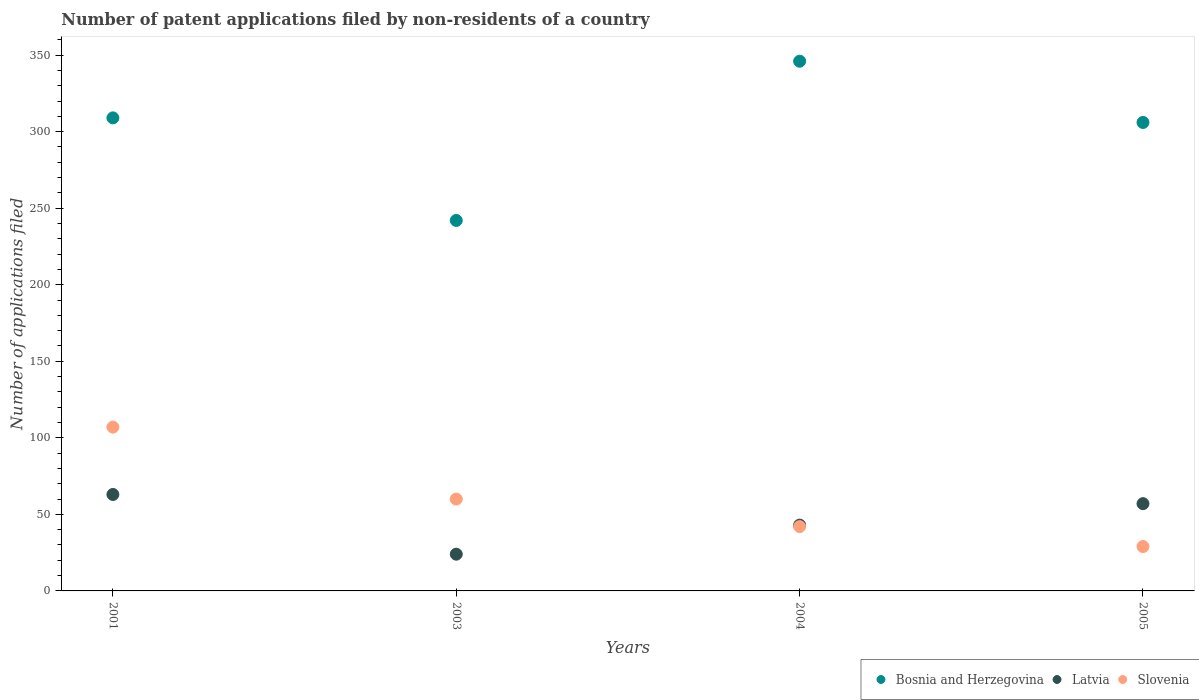How many different coloured dotlines are there?
Offer a terse response. 3. Is the number of dotlines equal to the number of legend labels?
Offer a very short reply. Yes. What is the number of applications filed in Slovenia in 2003?
Keep it short and to the point. 60. Across all years, what is the maximum number of applications filed in Bosnia and Herzegovina?
Offer a very short reply. 346. Across all years, what is the minimum number of applications filed in Slovenia?
Offer a terse response. 29. What is the total number of applications filed in Slovenia in the graph?
Keep it short and to the point. 238. What is the difference between the number of applications filed in Slovenia in 2004 and the number of applications filed in Latvia in 2005?
Keep it short and to the point. -15. What is the average number of applications filed in Bosnia and Herzegovina per year?
Provide a short and direct response. 300.75. In the year 2003, what is the difference between the number of applications filed in Bosnia and Herzegovina and number of applications filed in Slovenia?
Provide a short and direct response. 182. What is the ratio of the number of applications filed in Slovenia in 2003 to that in 2004?
Provide a short and direct response. 1.43. Is the number of applications filed in Bosnia and Herzegovina in 2001 less than that in 2003?
Your response must be concise. No. Does the number of applications filed in Latvia monotonically increase over the years?
Give a very brief answer. No. What is the difference between two consecutive major ticks on the Y-axis?
Make the answer very short. 50. Does the graph contain any zero values?
Provide a short and direct response. No. Where does the legend appear in the graph?
Provide a succinct answer. Bottom right. How many legend labels are there?
Keep it short and to the point. 3. What is the title of the graph?
Provide a short and direct response. Number of patent applications filed by non-residents of a country. What is the label or title of the Y-axis?
Make the answer very short. Number of applications filed. What is the Number of applications filed in Bosnia and Herzegovina in 2001?
Ensure brevity in your answer.  309. What is the Number of applications filed of Slovenia in 2001?
Make the answer very short. 107. What is the Number of applications filed in Bosnia and Herzegovina in 2003?
Ensure brevity in your answer.  242. What is the Number of applications filed of Latvia in 2003?
Your answer should be very brief. 24. What is the Number of applications filed in Bosnia and Herzegovina in 2004?
Give a very brief answer. 346. What is the Number of applications filed of Bosnia and Herzegovina in 2005?
Offer a very short reply. 306. What is the Number of applications filed of Latvia in 2005?
Your answer should be compact. 57. Across all years, what is the maximum Number of applications filed in Bosnia and Herzegovina?
Ensure brevity in your answer.  346. Across all years, what is the maximum Number of applications filed in Slovenia?
Provide a short and direct response. 107. Across all years, what is the minimum Number of applications filed in Bosnia and Herzegovina?
Ensure brevity in your answer.  242. Across all years, what is the minimum Number of applications filed in Slovenia?
Ensure brevity in your answer.  29. What is the total Number of applications filed in Bosnia and Herzegovina in the graph?
Give a very brief answer. 1203. What is the total Number of applications filed of Latvia in the graph?
Give a very brief answer. 187. What is the total Number of applications filed in Slovenia in the graph?
Keep it short and to the point. 238. What is the difference between the Number of applications filed in Bosnia and Herzegovina in 2001 and that in 2003?
Your response must be concise. 67. What is the difference between the Number of applications filed in Latvia in 2001 and that in 2003?
Keep it short and to the point. 39. What is the difference between the Number of applications filed of Slovenia in 2001 and that in 2003?
Provide a short and direct response. 47. What is the difference between the Number of applications filed in Bosnia and Herzegovina in 2001 and that in 2004?
Your answer should be very brief. -37. What is the difference between the Number of applications filed of Slovenia in 2001 and that in 2004?
Keep it short and to the point. 65. What is the difference between the Number of applications filed in Bosnia and Herzegovina in 2001 and that in 2005?
Give a very brief answer. 3. What is the difference between the Number of applications filed in Latvia in 2001 and that in 2005?
Your response must be concise. 6. What is the difference between the Number of applications filed of Bosnia and Herzegovina in 2003 and that in 2004?
Ensure brevity in your answer.  -104. What is the difference between the Number of applications filed of Latvia in 2003 and that in 2004?
Provide a succinct answer. -19. What is the difference between the Number of applications filed of Bosnia and Herzegovina in 2003 and that in 2005?
Provide a succinct answer. -64. What is the difference between the Number of applications filed in Latvia in 2003 and that in 2005?
Your answer should be compact. -33. What is the difference between the Number of applications filed in Slovenia in 2003 and that in 2005?
Provide a succinct answer. 31. What is the difference between the Number of applications filed in Latvia in 2004 and that in 2005?
Make the answer very short. -14. What is the difference between the Number of applications filed of Bosnia and Herzegovina in 2001 and the Number of applications filed of Latvia in 2003?
Make the answer very short. 285. What is the difference between the Number of applications filed of Bosnia and Herzegovina in 2001 and the Number of applications filed of Slovenia in 2003?
Provide a succinct answer. 249. What is the difference between the Number of applications filed in Bosnia and Herzegovina in 2001 and the Number of applications filed in Latvia in 2004?
Your response must be concise. 266. What is the difference between the Number of applications filed in Bosnia and Herzegovina in 2001 and the Number of applications filed in Slovenia in 2004?
Give a very brief answer. 267. What is the difference between the Number of applications filed in Bosnia and Herzegovina in 2001 and the Number of applications filed in Latvia in 2005?
Ensure brevity in your answer.  252. What is the difference between the Number of applications filed in Bosnia and Herzegovina in 2001 and the Number of applications filed in Slovenia in 2005?
Your answer should be very brief. 280. What is the difference between the Number of applications filed of Latvia in 2001 and the Number of applications filed of Slovenia in 2005?
Your answer should be compact. 34. What is the difference between the Number of applications filed of Bosnia and Herzegovina in 2003 and the Number of applications filed of Latvia in 2004?
Make the answer very short. 199. What is the difference between the Number of applications filed in Latvia in 2003 and the Number of applications filed in Slovenia in 2004?
Ensure brevity in your answer.  -18. What is the difference between the Number of applications filed in Bosnia and Herzegovina in 2003 and the Number of applications filed in Latvia in 2005?
Your answer should be very brief. 185. What is the difference between the Number of applications filed in Bosnia and Herzegovina in 2003 and the Number of applications filed in Slovenia in 2005?
Provide a short and direct response. 213. What is the difference between the Number of applications filed in Bosnia and Herzegovina in 2004 and the Number of applications filed in Latvia in 2005?
Keep it short and to the point. 289. What is the difference between the Number of applications filed of Bosnia and Herzegovina in 2004 and the Number of applications filed of Slovenia in 2005?
Provide a succinct answer. 317. What is the difference between the Number of applications filed of Latvia in 2004 and the Number of applications filed of Slovenia in 2005?
Your answer should be very brief. 14. What is the average Number of applications filed of Bosnia and Herzegovina per year?
Provide a short and direct response. 300.75. What is the average Number of applications filed in Latvia per year?
Provide a succinct answer. 46.75. What is the average Number of applications filed of Slovenia per year?
Your answer should be compact. 59.5. In the year 2001, what is the difference between the Number of applications filed in Bosnia and Herzegovina and Number of applications filed in Latvia?
Ensure brevity in your answer.  246. In the year 2001, what is the difference between the Number of applications filed of Bosnia and Herzegovina and Number of applications filed of Slovenia?
Give a very brief answer. 202. In the year 2001, what is the difference between the Number of applications filed of Latvia and Number of applications filed of Slovenia?
Your answer should be very brief. -44. In the year 2003, what is the difference between the Number of applications filed of Bosnia and Herzegovina and Number of applications filed of Latvia?
Keep it short and to the point. 218. In the year 2003, what is the difference between the Number of applications filed of Bosnia and Herzegovina and Number of applications filed of Slovenia?
Your response must be concise. 182. In the year 2003, what is the difference between the Number of applications filed in Latvia and Number of applications filed in Slovenia?
Offer a very short reply. -36. In the year 2004, what is the difference between the Number of applications filed in Bosnia and Herzegovina and Number of applications filed in Latvia?
Keep it short and to the point. 303. In the year 2004, what is the difference between the Number of applications filed in Bosnia and Herzegovina and Number of applications filed in Slovenia?
Provide a short and direct response. 304. In the year 2004, what is the difference between the Number of applications filed in Latvia and Number of applications filed in Slovenia?
Keep it short and to the point. 1. In the year 2005, what is the difference between the Number of applications filed of Bosnia and Herzegovina and Number of applications filed of Latvia?
Provide a short and direct response. 249. In the year 2005, what is the difference between the Number of applications filed in Bosnia and Herzegovina and Number of applications filed in Slovenia?
Ensure brevity in your answer.  277. In the year 2005, what is the difference between the Number of applications filed in Latvia and Number of applications filed in Slovenia?
Provide a succinct answer. 28. What is the ratio of the Number of applications filed of Bosnia and Herzegovina in 2001 to that in 2003?
Provide a short and direct response. 1.28. What is the ratio of the Number of applications filed of Latvia in 2001 to that in 2003?
Offer a terse response. 2.62. What is the ratio of the Number of applications filed in Slovenia in 2001 to that in 2003?
Your answer should be compact. 1.78. What is the ratio of the Number of applications filed in Bosnia and Herzegovina in 2001 to that in 2004?
Ensure brevity in your answer.  0.89. What is the ratio of the Number of applications filed of Latvia in 2001 to that in 2004?
Make the answer very short. 1.47. What is the ratio of the Number of applications filed of Slovenia in 2001 to that in 2004?
Your response must be concise. 2.55. What is the ratio of the Number of applications filed in Bosnia and Herzegovina in 2001 to that in 2005?
Your answer should be very brief. 1.01. What is the ratio of the Number of applications filed of Latvia in 2001 to that in 2005?
Provide a succinct answer. 1.11. What is the ratio of the Number of applications filed of Slovenia in 2001 to that in 2005?
Make the answer very short. 3.69. What is the ratio of the Number of applications filed in Bosnia and Herzegovina in 2003 to that in 2004?
Your answer should be compact. 0.7. What is the ratio of the Number of applications filed in Latvia in 2003 to that in 2004?
Your answer should be very brief. 0.56. What is the ratio of the Number of applications filed of Slovenia in 2003 to that in 2004?
Your response must be concise. 1.43. What is the ratio of the Number of applications filed in Bosnia and Herzegovina in 2003 to that in 2005?
Give a very brief answer. 0.79. What is the ratio of the Number of applications filed of Latvia in 2003 to that in 2005?
Your answer should be compact. 0.42. What is the ratio of the Number of applications filed of Slovenia in 2003 to that in 2005?
Offer a very short reply. 2.07. What is the ratio of the Number of applications filed in Bosnia and Herzegovina in 2004 to that in 2005?
Keep it short and to the point. 1.13. What is the ratio of the Number of applications filed of Latvia in 2004 to that in 2005?
Ensure brevity in your answer.  0.75. What is the ratio of the Number of applications filed of Slovenia in 2004 to that in 2005?
Provide a short and direct response. 1.45. What is the difference between the highest and the second highest Number of applications filed in Latvia?
Your answer should be very brief. 6. What is the difference between the highest and the second highest Number of applications filed of Slovenia?
Offer a very short reply. 47. What is the difference between the highest and the lowest Number of applications filed in Bosnia and Herzegovina?
Make the answer very short. 104. What is the difference between the highest and the lowest Number of applications filed in Slovenia?
Ensure brevity in your answer.  78. 